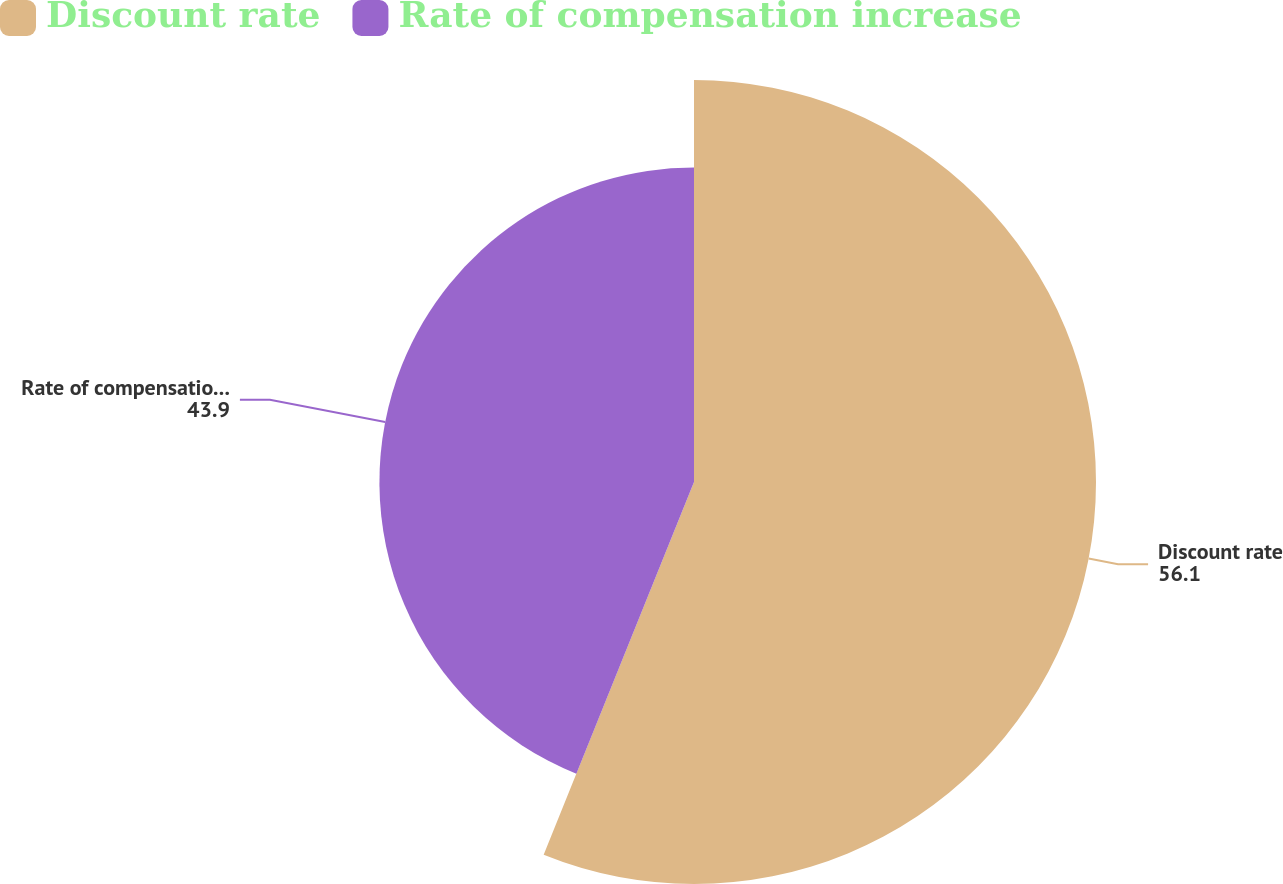Convert chart. <chart><loc_0><loc_0><loc_500><loc_500><pie_chart><fcel>Discount rate<fcel>Rate of compensation increase<nl><fcel>56.1%<fcel>43.9%<nl></chart> 